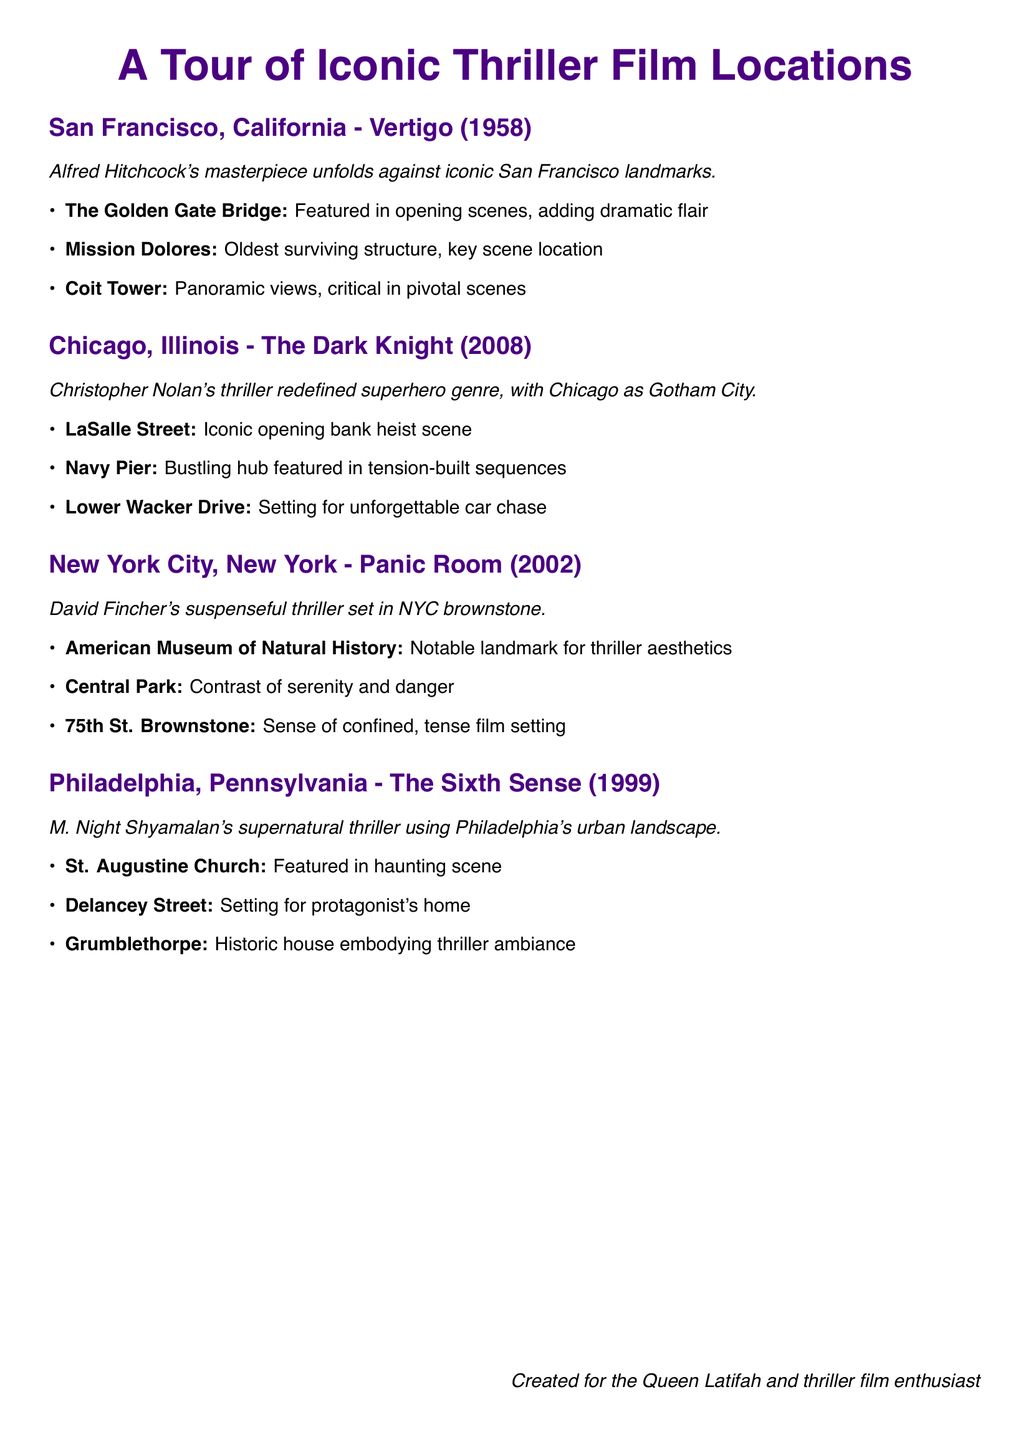what is the first city listed in the itinerary? The first city listed in the itinerary is San Francisco, California, mentioned in the section about "Vertigo"
Answer: San Francisco, California which film features locations in Chicago, Illinois? The film that features locations in Chicago, Illinois is "The Dark Knight"
Answer: The Dark Knight how many key locations are listed under Philadelphia for "The Sixth Sense"? The document lists three key locations under Philadelphia for "The Sixth Sense"
Answer: three what is the significance of the Golden Gate Bridge in "Vertigo"? The Golden Gate Bridge is featured in the opening scenes, adding dramatic flair to the film
Answer: Dramatic flair which museum is noted in the itinerary for its connection to "Panic Room"? The American Museum of Natural History is noted for its connection to "Panic Room"
Answer: American Museum of Natural History what type of structure is Mission Dolores? Mission Dolores is noted as the oldest surviving structure in San Francisco, key in a scene
Answer: Oldest surviving structure what kind of film is "Panic Room" categorized as? "Panic Room" is categorized as a suspenseful thriller
Answer: Suspenseful thriller which historical house is mentioned in association with "The Sixth Sense"? Grumblethorpe is the historical house mentioned in association with "The Sixth Sense"
Answer: Grumblethorpe 